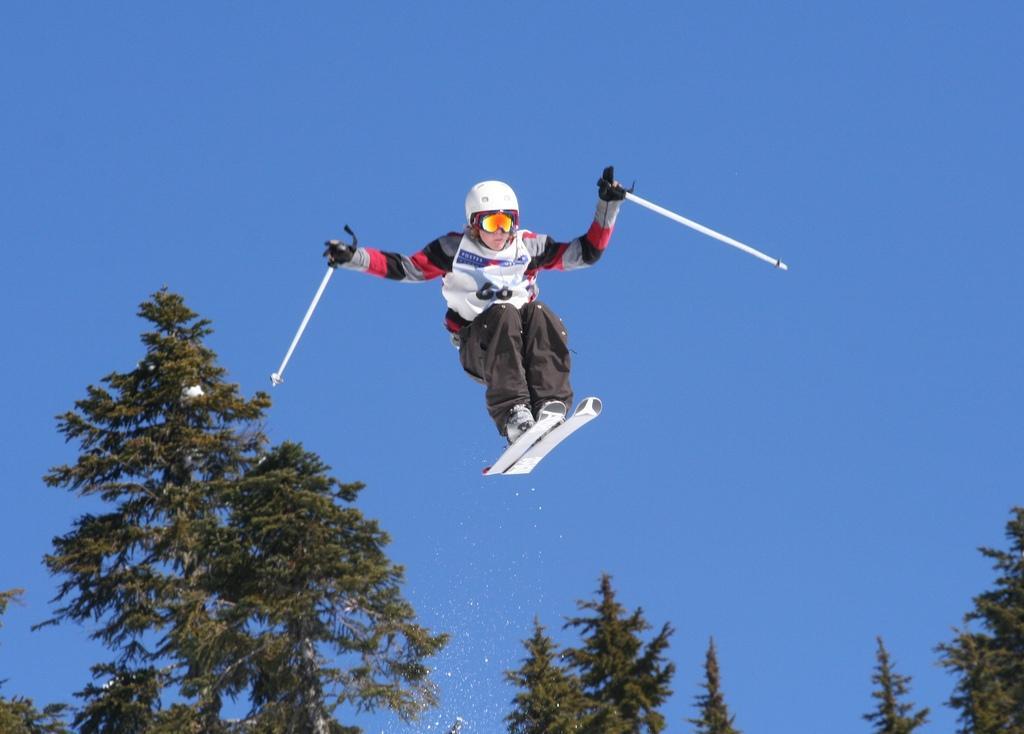Could you give a brief overview of what you see in this image? In the center of the image we can see a person wearing the helmet and skis holding the sticks. We can also see a group of trees and the sky which looks cloudy. 